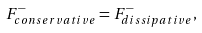Convert formula to latex. <formula><loc_0><loc_0><loc_500><loc_500>F _ { c o n s e r v a t i v e } ^ { - } = F _ { d i s s i p a t i v e } ^ { - } ,</formula> 